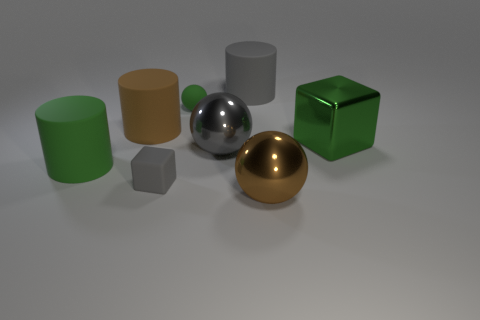Are there more metallic spheres that are on the left side of the large gray cylinder than brown matte cylinders that are right of the green sphere?
Provide a succinct answer. Yes. What material is the gray cube?
Ensure brevity in your answer.  Rubber. The gray matte thing behind the big green object left of the large matte thing that is behind the tiny ball is what shape?
Keep it short and to the point. Cylinder. How many other things are there of the same material as the big gray cylinder?
Your response must be concise. 4. Is the big ball to the right of the gray cylinder made of the same material as the cylinder right of the small cube?
Make the answer very short. No. How many big things are both in front of the gray cylinder and left of the shiny cube?
Your response must be concise. 4. Are there any big purple metal objects of the same shape as the small gray rubber object?
Your response must be concise. No. The gray metallic thing that is the same size as the green shiny thing is what shape?
Provide a short and direct response. Sphere. Are there the same number of gray metal balls behind the green rubber sphere and big green metallic cubes on the left side of the gray sphere?
Offer a very short reply. Yes. How big is the matte cylinder that is behind the brown thing that is left of the large brown shiny ball?
Provide a short and direct response. Large. 